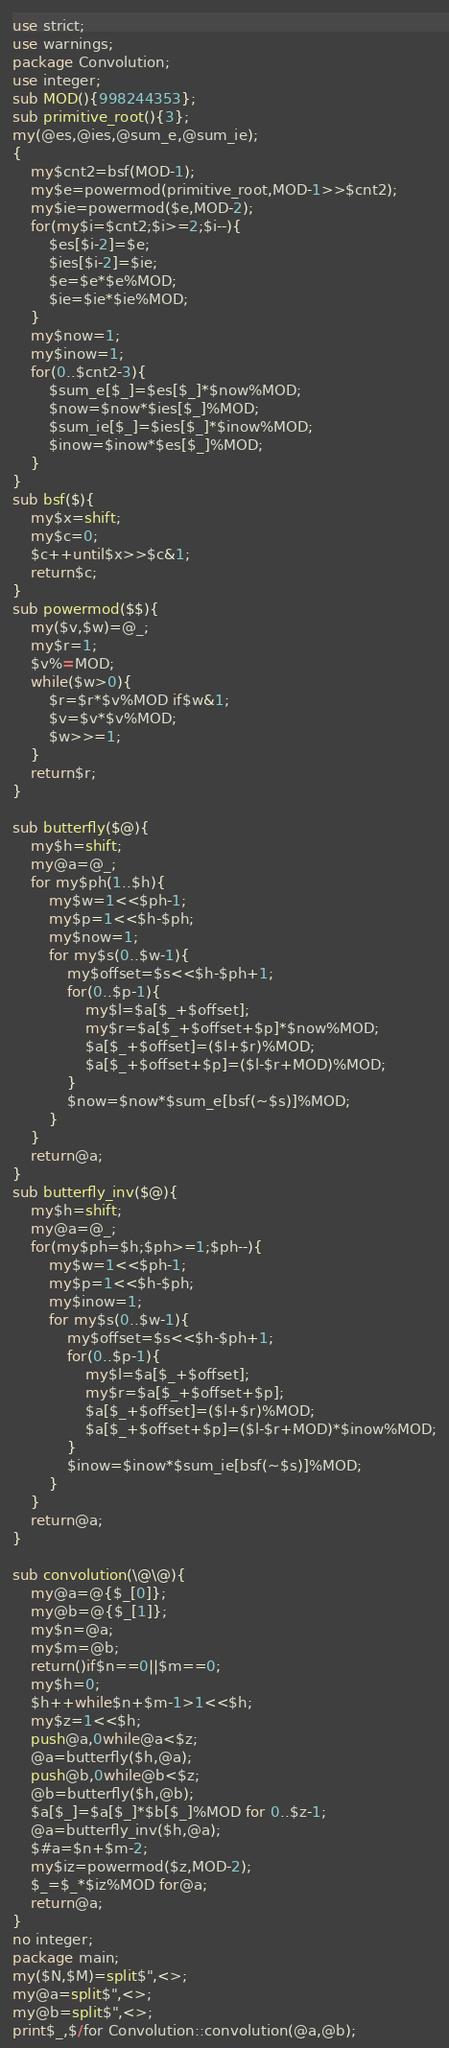<code> <loc_0><loc_0><loc_500><loc_500><_Perl_>use strict;
use warnings;
package Convolution;
use integer;
sub MOD(){998244353};
sub primitive_root(){3};
my(@es,@ies,@sum_e,@sum_ie);
{
	my$cnt2=bsf(MOD-1);
	my$e=powermod(primitive_root,MOD-1>>$cnt2);
	my$ie=powermod($e,MOD-2);
	for(my$i=$cnt2;$i>=2;$i--){
		$es[$i-2]=$e;
		$ies[$i-2]=$ie;
		$e=$e*$e%MOD;
		$ie=$ie*$ie%MOD;
	}
	my$now=1;
	my$inow=1;
	for(0..$cnt2-3){
		$sum_e[$_]=$es[$_]*$now%MOD;
		$now=$now*$ies[$_]%MOD;
		$sum_ie[$_]=$ies[$_]*$inow%MOD;
		$inow=$inow*$es[$_]%MOD;
	}
}
sub bsf($){
	my$x=shift;
	my$c=0;
	$c++until$x>>$c&1;
	return$c;
}
sub powermod($$){
	my($v,$w)=@_;
	my$r=1;
	$v%=MOD;
	while($w>0){
		$r=$r*$v%MOD if$w&1;
		$v=$v*$v%MOD;
		$w>>=1;
	}
	return$r;
}

sub butterfly($@){
	my$h=shift;
	my@a=@_;
	for my$ph(1..$h){
		my$w=1<<$ph-1;
		my$p=1<<$h-$ph;
		my$now=1;
		for my$s(0..$w-1){
			my$offset=$s<<$h-$ph+1;
			for(0..$p-1){
				my$l=$a[$_+$offset];
				my$r=$a[$_+$offset+$p]*$now%MOD;
				$a[$_+$offset]=($l+$r)%MOD;
				$a[$_+$offset+$p]=($l-$r+MOD)%MOD;
			}
			$now=$now*$sum_e[bsf(~$s)]%MOD;
		}
	}
	return@a;
}
sub butterfly_inv($@){
	my$h=shift;
	my@a=@_;
	for(my$ph=$h;$ph>=1;$ph--){
		my$w=1<<$ph-1;
		my$p=1<<$h-$ph;
		my$inow=1;
		for my$s(0..$w-1){
			my$offset=$s<<$h-$ph+1;
			for(0..$p-1){
				my$l=$a[$_+$offset];
				my$r=$a[$_+$offset+$p];
				$a[$_+$offset]=($l+$r)%MOD;
				$a[$_+$offset+$p]=($l-$r+MOD)*$inow%MOD;
			}
			$inow=$inow*$sum_ie[bsf(~$s)]%MOD;
		}
	}
	return@a;
}

sub convolution(\@\@){
	my@a=@{$_[0]};
	my@b=@{$_[1]};
	my$n=@a;
	my$m=@b;
	return()if$n==0||$m==0;
	my$h=0;
	$h++while$n+$m-1>1<<$h;
	my$z=1<<$h;
	push@a,0while@a<$z;
	@a=butterfly($h,@a);
	push@b,0while@b<$z;
	@b=butterfly($h,@b);
	$a[$_]=$a[$_]*$b[$_]%MOD for 0..$z-1;
	@a=butterfly_inv($h,@a);
	$#a=$n+$m-2;
	my$iz=powermod($z,MOD-2);
	$_=$_*$iz%MOD for@a;
	return@a;
}
no integer;
package main;
my($N,$M)=split$",<>;
my@a=split$",<>;
my@b=split$",<>;
print$_,$/for Convolution::convolution(@a,@b);
</code> 